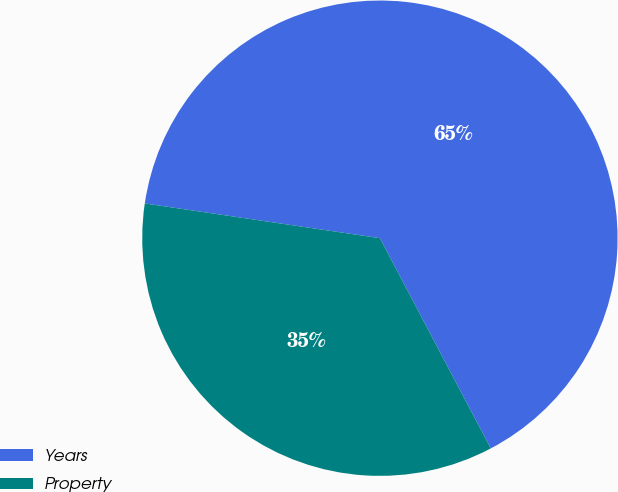Convert chart to OTSL. <chart><loc_0><loc_0><loc_500><loc_500><pie_chart><fcel>Years<fcel>Property<nl><fcel>64.94%<fcel>35.06%<nl></chart> 